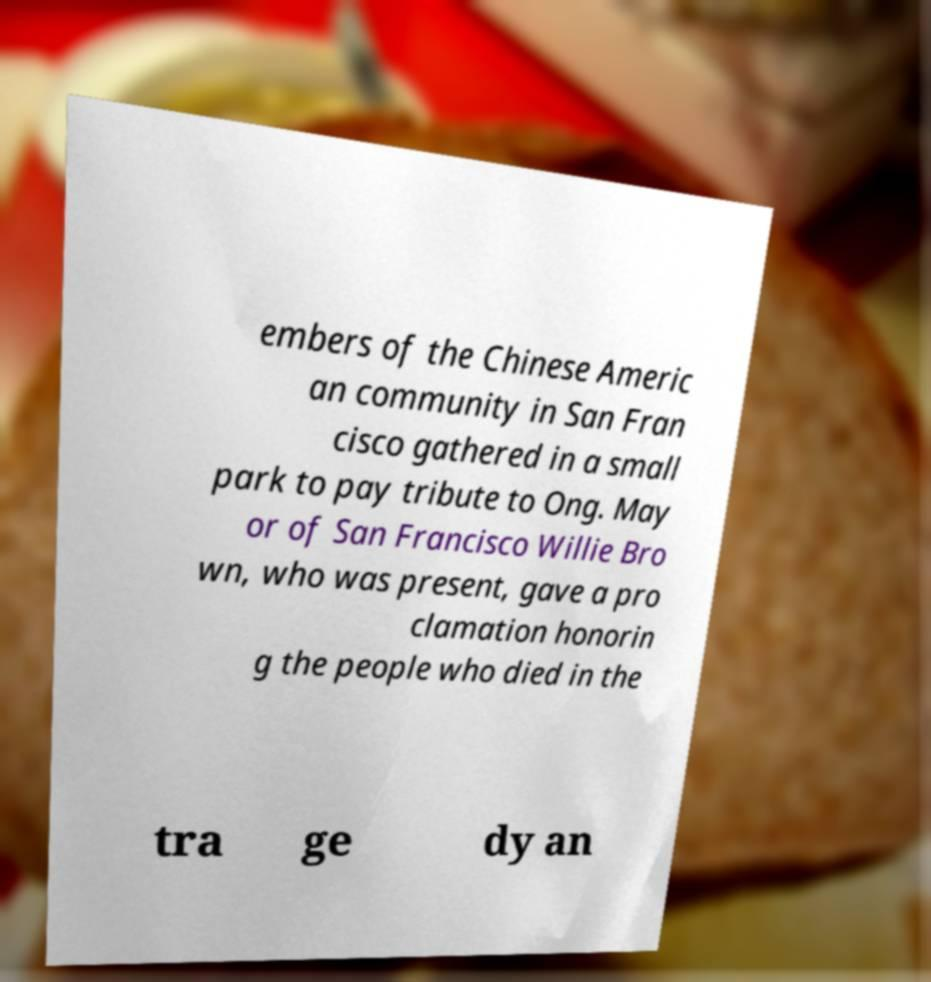There's text embedded in this image that I need extracted. Can you transcribe it verbatim? embers of the Chinese Americ an community in San Fran cisco gathered in a small park to pay tribute to Ong. May or of San Francisco Willie Bro wn, who was present, gave a pro clamation honorin g the people who died in the tra ge dy an 